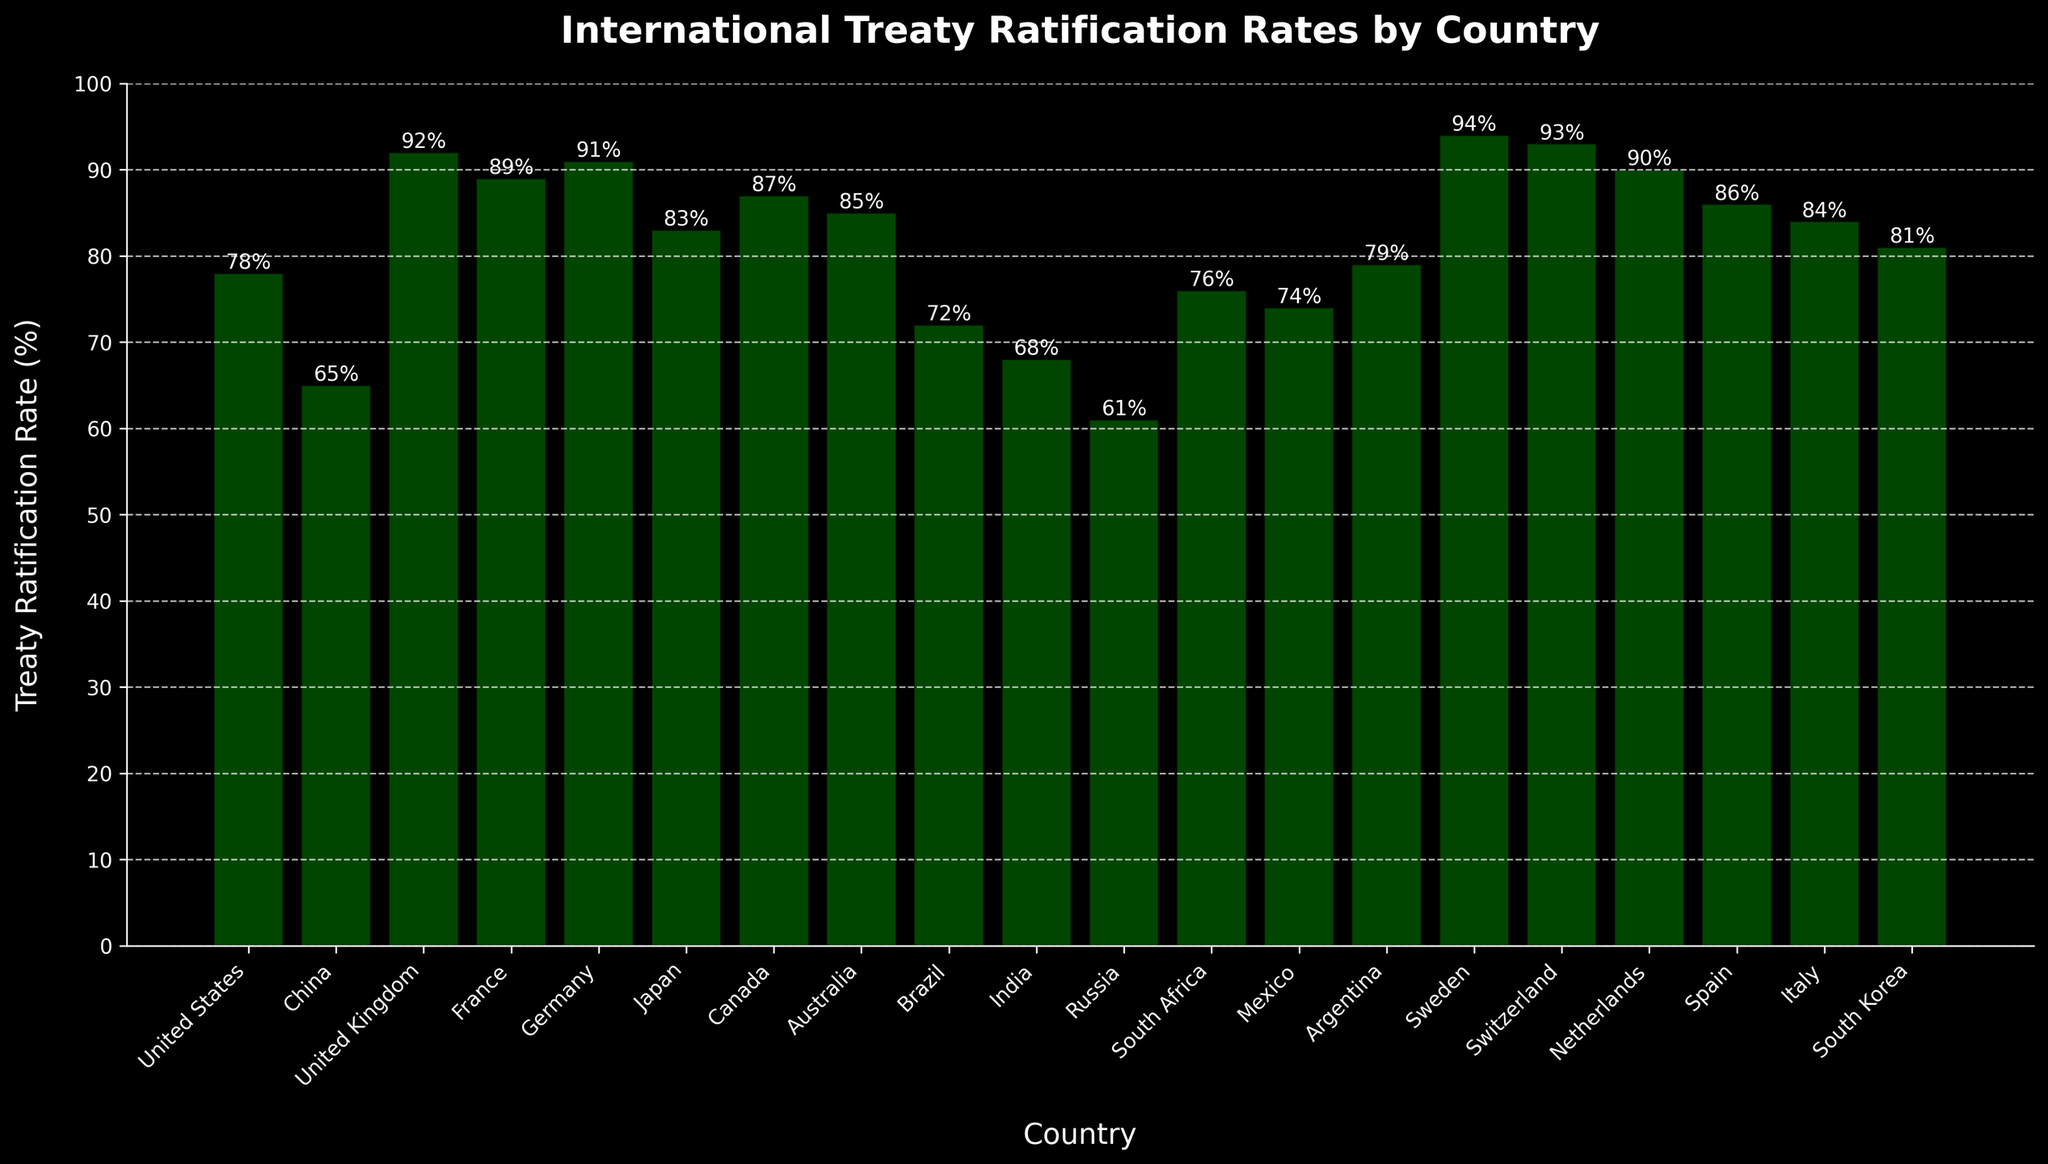Which country has the highest treaty ratification rate? The highest bar in the chart represents the country with the highest treaty ratification rate. By observing the height, Sweden has the highest rate at 94%.
Answer: Sweden Which country has the lowest treaty ratification rate? The lowest bar in the chart represents the country with the lowest treaty ratification rate. By observing the height, Russia has the lowest rate at 61%.
Answer: Russia Compare the treaty ratification rates between the United States and Canada. Look at the height of the bars for the United States and Canada. The United States has a rate of 78%, while Canada has a rate of 87%. Canada has a higher rate than the United States.
Answer: Canada has a higher rate What is the average treaty ratification rate for the countries displayed in the chart? To find the average, sum the rates of all countries and divide by the number of countries: (78+65+92+89+91+83+87+85+72+68+61+76+74+79+94+93+90+86+84+81) / 20 = 81.95%.
Answer: 82% How many countries have a treaty ratification rate of 90% or above? Count the bars that reach 90% or higher. The countries with rates 90% or above are the United Kingdom (92%), France (89%), Germany (91%), Sweden (94%), Switzerland (93%), and the Netherlands (90%) - 6 in total.
Answer: 6 What is the difference in treaty ratification rates between France and Italy? Look at the heights of the bars for France and Italy. France has a rate of 89%, and Italy has a rate of 84%. The difference is 89% - 84% = 5%.
Answer: 5% Which countries have a treaty ratification rate between 80% and 90%? Identify the bars that fall within this range. The countries are Japan (83%), Canada (87%), Australia (85%), Spain (86%), Italy (84%), and South Korea (81%).
Answer: Japan, Canada, Australia, Spain, Italy, South Korea What is the combined treaty ratification rate of Brazil and Mexico? Add the rates of Brazil and Mexico. Brazil has a rate of 72%, and Mexico has a rate of 74%. The combined rate is 72% + 74% = 146%.
Answer: 146% Which country has a treaty ratification rate closest to 80%? Find the bar with a rate closest to 80%. South Korea's rate is 81%, which is the closest to 80%.
Answer: South Korea What is the median treaty ratification rate for the countries displayed in the chart? Arrange the rates in ascending order: 61, 65, 68, 72, 74, 76, 78, 79, 81, 83, 84, 85, 86, 87, 89, 90, 91, 92, 93, 94. The median rate is the middle value in the ordered list, which is the average of 84 and 85 (since there are 20 countries), so (84+85)/2 = 84.5%.
Answer: 84.5% 